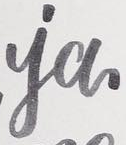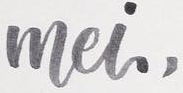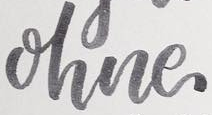What text is displayed in these images sequentially, separated by a semicolon? ia; mei,; ohne 